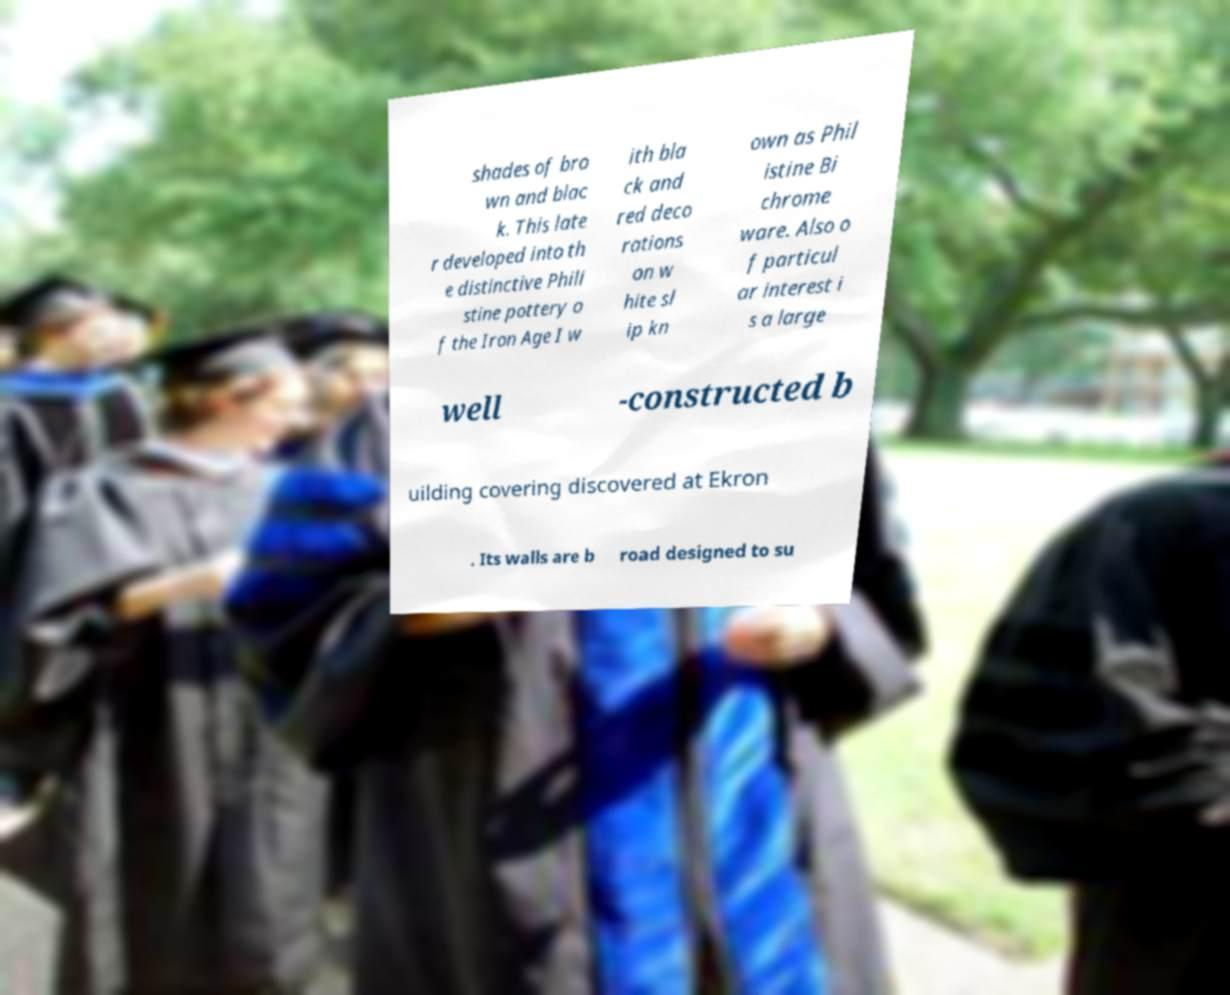Please identify and transcribe the text found in this image. shades of bro wn and blac k. This late r developed into th e distinctive Phili stine pottery o f the Iron Age I w ith bla ck and red deco rations on w hite sl ip kn own as Phil istine Bi chrome ware. Also o f particul ar interest i s a large well -constructed b uilding covering discovered at Ekron . Its walls are b road designed to su 